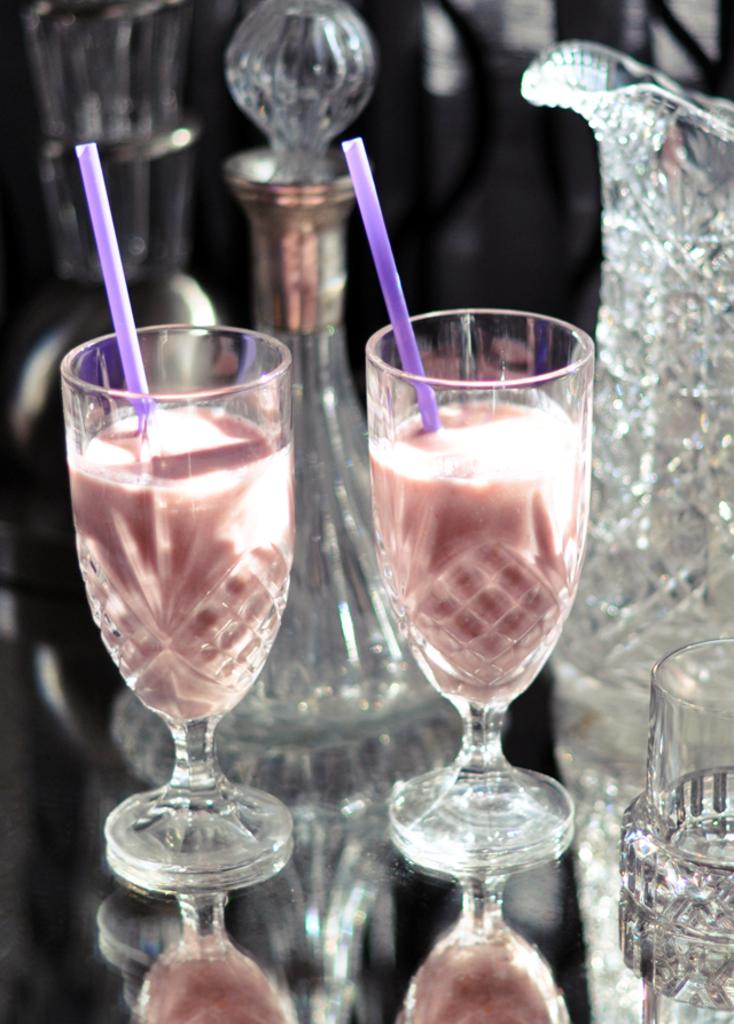How many glasses can be seen in the image? There are two glasses in the image. What is inside the glasses? There is liquid in the glasses. What are the glasses being used for? The glasses have straws in them, suggesting they are being used to drink the liquid. Can you describe the reflection in the image? The image contains a reflection of the glasses. How would you describe the background of the image? The background of the image is slightly blurred. What type of plants can be seen growing in the glasses? There are no plants visible in the glasses; they contain liquid and straws. 